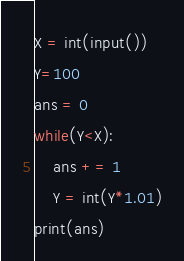Convert code to text. <code><loc_0><loc_0><loc_500><loc_500><_Python_>X = int(input())
Y=100
ans = 0
while(Y<X):
    ans += 1
    Y = int(Y*1.01)
print(ans)</code> 